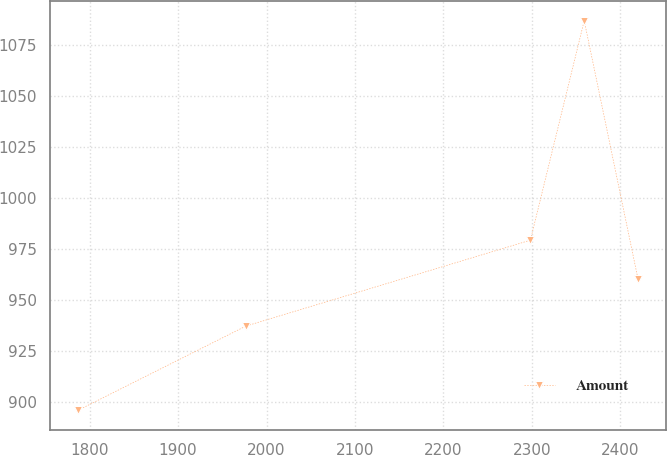<chart> <loc_0><loc_0><loc_500><loc_500><line_chart><ecel><fcel>Amount<nl><fcel>1786.82<fcel>895.98<nl><fcel>1976.58<fcel>937.28<nl><fcel>2298.34<fcel>979.42<nl><fcel>2359.18<fcel>1087.06<nl><fcel>2420.02<fcel>960.31<nl></chart> 